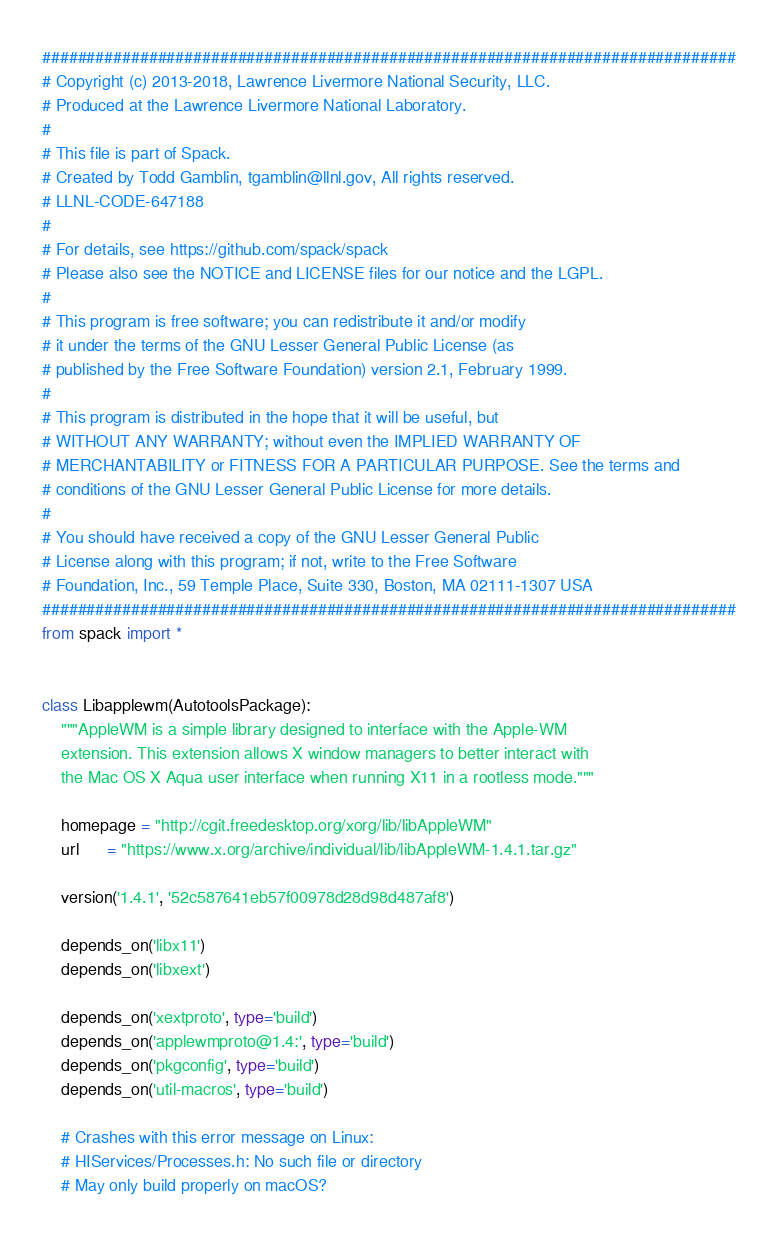<code> <loc_0><loc_0><loc_500><loc_500><_Python_>##############################################################################
# Copyright (c) 2013-2018, Lawrence Livermore National Security, LLC.
# Produced at the Lawrence Livermore National Laboratory.
#
# This file is part of Spack.
# Created by Todd Gamblin, tgamblin@llnl.gov, All rights reserved.
# LLNL-CODE-647188
#
# For details, see https://github.com/spack/spack
# Please also see the NOTICE and LICENSE files for our notice and the LGPL.
#
# This program is free software; you can redistribute it and/or modify
# it under the terms of the GNU Lesser General Public License (as
# published by the Free Software Foundation) version 2.1, February 1999.
#
# This program is distributed in the hope that it will be useful, but
# WITHOUT ANY WARRANTY; without even the IMPLIED WARRANTY OF
# MERCHANTABILITY or FITNESS FOR A PARTICULAR PURPOSE. See the terms and
# conditions of the GNU Lesser General Public License for more details.
#
# You should have received a copy of the GNU Lesser General Public
# License along with this program; if not, write to the Free Software
# Foundation, Inc., 59 Temple Place, Suite 330, Boston, MA 02111-1307 USA
##############################################################################
from spack import *


class Libapplewm(AutotoolsPackage):
    """AppleWM is a simple library designed to interface with the Apple-WM
    extension. This extension allows X window managers to better interact with
    the Mac OS X Aqua user interface when running X11 in a rootless mode."""

    homepage = "http://cgit.freedesktop.org/xorg/lib/libAppleWM"
    url      = "https://www.x.org/archive/individual/lib/libAppleWM-1.4.1.tar.gz"

    version('1.4.1', '52c587641eb57f00978d28d98d487af8')

    depends_on('libx11')
    depends_on('libxext')

    depends_on('xextproto', type='build')
    depends_on('applewmproto@1.4:', type='build')
    depends_on('pkgconfig', type='build')
    depends_on('util-macros', type='build')

    # Crashes with this error message on Linux:
    # HIServices/Processes.h: No such file or directory
    # May only build properly on macOS?
</code> 